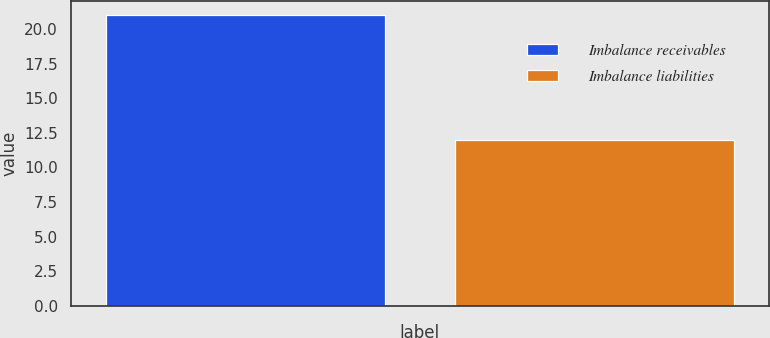Convert chart to OTSL. <chart><loc_0><loc_0><loc_500><loc_500><bar_chart><fcel>Imbalance receivables<fcel>Imbalance liabilities<nl><fcel>21<fcel>12<nl></chart> 